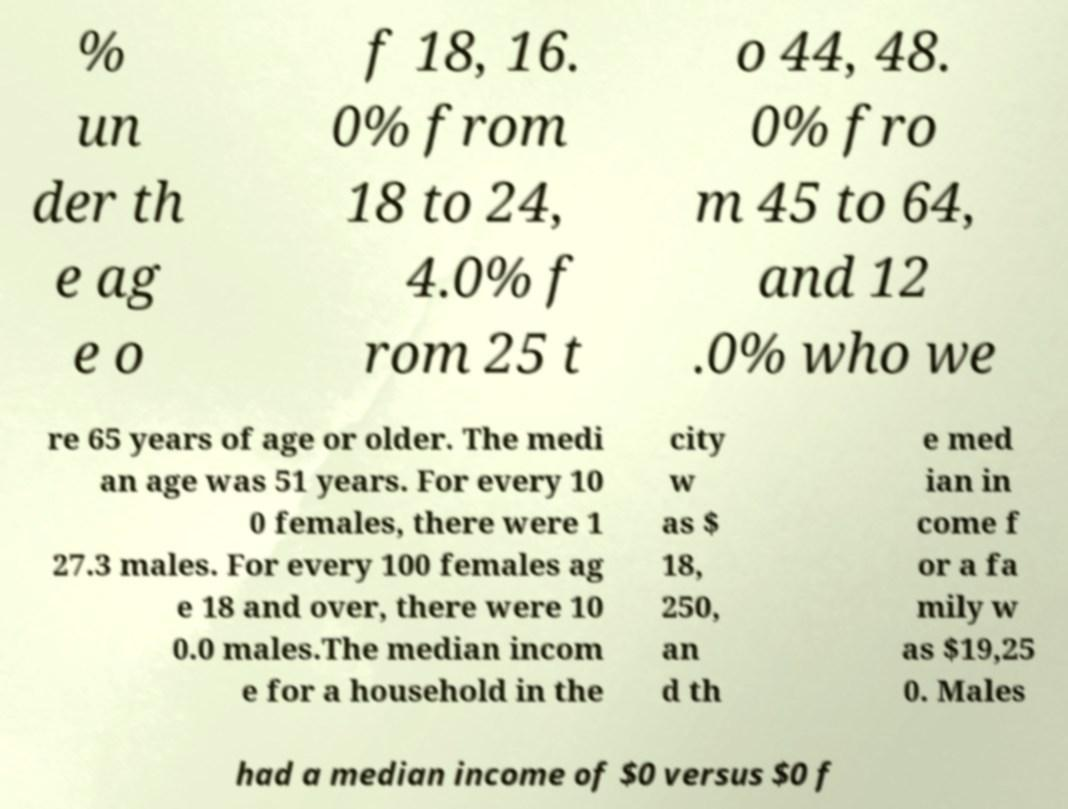Please identify and transcribe the text found in this image. % un der th e ag e o f 18, 16. 0% from 18 to 24, 4.0% f rom 25 t o 44, 48. 0% fro m 45 to 64, and 12 .0% who we re 65 years of age or older. The medi an age was 51 years. For every 10 0 females, there were 1 27.3 males. For every 100 females ag e 18 and over, there were 10 0.0 males.The median incom e for a household in the city w as $ 18, 250, an d th e med ian in come f or a fa mily w as $19,25 0. Males had a median income of $0 versus $0 f 